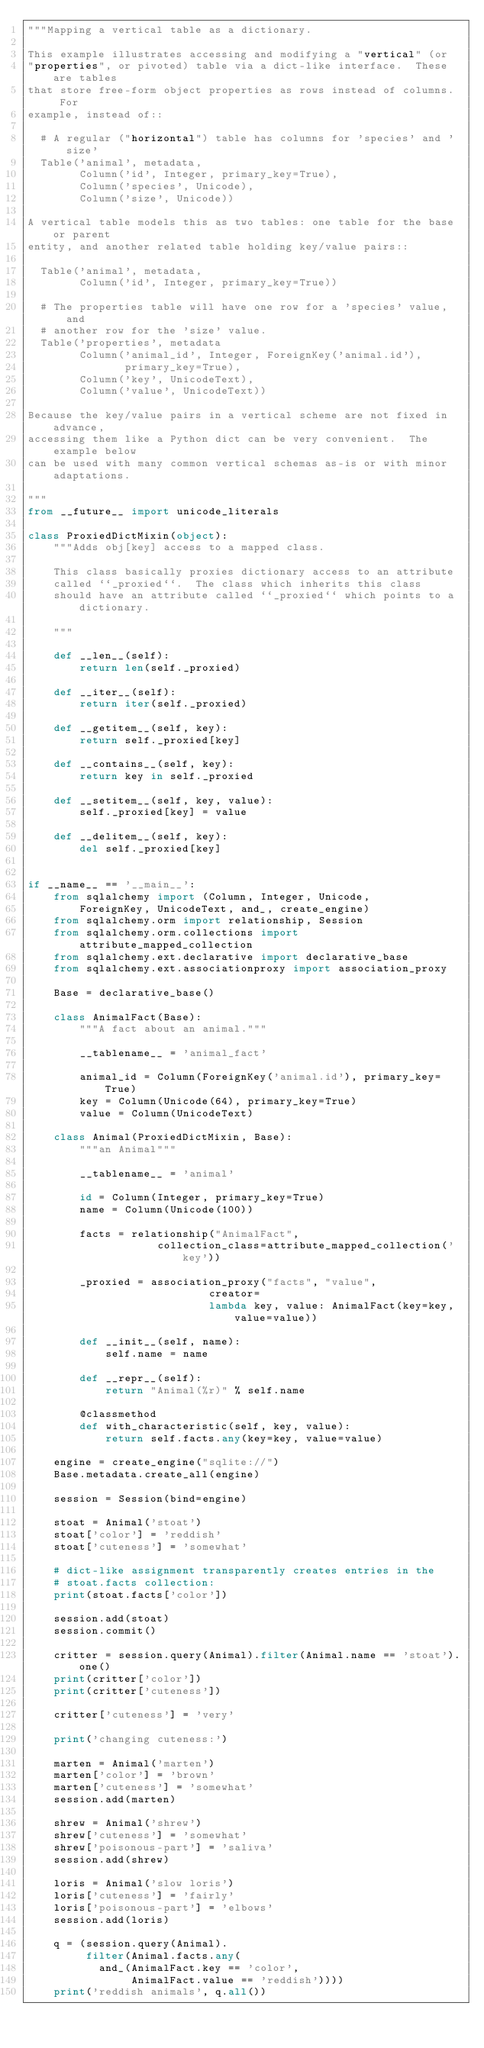<code> <loc_0><loc_0><loc_500><loc_500><_Python_>"""Mapping a vertical table as a dictionary.

This example illustrates accessing and modifying a "vertical" (or
"properties", or pivoted) table via a dict-like interface.  These are tables
that store free-form object properties as rows instead of columns.  For
example, instead of::

  # A regular ("horizontal") table has columns for 'species' and 'size'
  Table('animal', metadata,
        Column('id', Integer, primary_key=True),
        Column('species', Unicode),
        Column('size', Unicode))

A vertical table models this as two tables: one table for the base or parent
entity, and another related table holding key/value pairs::

  Table('animal', metadata,
        Column('id', Integer, primary_key=True))

  # The properties table will have one row for a 'species' value, and
  # another row for the 'size' value.
  Table('properties', metadata
        Column('animal_id', Integer, ForeignKey('animal.id'),
               primary_key=True),
        Column('key', UnicodeText),
        Column('value', UnicodeText))

Because the key/value pairs in a vertical scheme are not fixed in advance,
accessing them like a Python dict can be very convenient.  The example below
can be used with many common vertical schemas as-is or with minor adaptations.

"""
from __future__ import unicode_literals

class ProxiedDictMixin(object):
    """Adds obj[key] access to a mapped class.

    This class basically proxies dictionary access to an attribute
    called ``_proxied``.  The class which inherits this class
    should have an attribute called ``_proxied`` which points to a dictionary.

    """

    def __len__(self):
        return len(self._proxied)

    def __iter__(self):
        return iter(self._proxied)

    def __getitem__(self, key):
        return self._proxied[key]

    def __contains__(self, key):
        return key in self._proxied

    def __setitem__(self, key, value):
        self._proxied[key] = value

    def __delitem__(self, key):
        del self._proxied[key]


if __name__ == '__main__':
    from sqlalchemy import (Column, Integer, Unicode,
        ForeignKey, UnicodeText, and_, create_engine)
    from sqlalchemy.orm import relationship, Session
    from sqlalchemy.orm.collections import attribute_mapped_collection
    from sqlalchemy.ext.declarative import declarative_base
    from sqlalchemy.ext.associationproxy import association_proxy

    Base = declarative_base()

    class AnimalFact(Base):
        """A fact about an animal."""

        __tablename__ = 'animal_fact'

        animal_id = Column(ForeignKey('animal.id'), primary_key=True)
        key = Column(Unicode(64), primary_key=True)
        value = Column(UnicodeText)

    class Animal(ProxiedDictMixin, Base):
        """an Animal"""

        __tablename__ = 'animal'

        id = Column(Integer, primary_key=True)
        name = Column(Unicode(100))

        facts = relationship("AnimalFact",
                    collection_class=attribute_mapped_collection('key'))

        _proxied = association_proxy("facts", "value",
                            creator=
                            lambda key, value: AnimalFact(key=key, value=value))

        def __init__(self, name):
            self.name = name

        def __repr__(self):
            return "Animal(%r)" % self.name

        @classmethod
        def with_characteristic(self, key, value):
            return self.facts.any(key=key, value=value)

    engine = create_engine("sqlite://")
    Base.metadata.create_all(engine)

    session = Session(bind=engine)

    stoat = Animal('stoat')
    stoat['color'] = 'reddish'
    stoat['cuteness'] = 'somewhat'

    # dict-like assignment transparently creates entries in the
    # stoat.facts collection:
    print(stoat.facts['color'])

    session.add(stoat)
    session.commit()

    critter = session.query(Animal).filter(Animal.name == 'stoat').one()
    print(critter['color'])
    print(critter['cuteness'])

    critter['cuteness'] = 'very'

    print('changing cuteness:')

    marten = Animal('marten')
    marten['color'] = 'brown'
    marten['cuteness'] = 'somewhat'
    session.add(marten)

    shrew = Animal('shrew')
    shrew['cuteness'] = 'somewhat'
    shrew['poisonous-part'] = 'saliva'
    session.add(shrew)

    loris = Animal('slow loris')
    loris['cuteness'] = 'fairly'
    loris['poisonous-part'] = 'elbows'
    session.add(loris)

    q = (session.query(Animal).
         filter(Animal.facts.any(
           and_(AnimalFact.key == 'color',
                AnimalFact.value == 'reddish'))))
    print('reddish animals', q.all())
</code> 